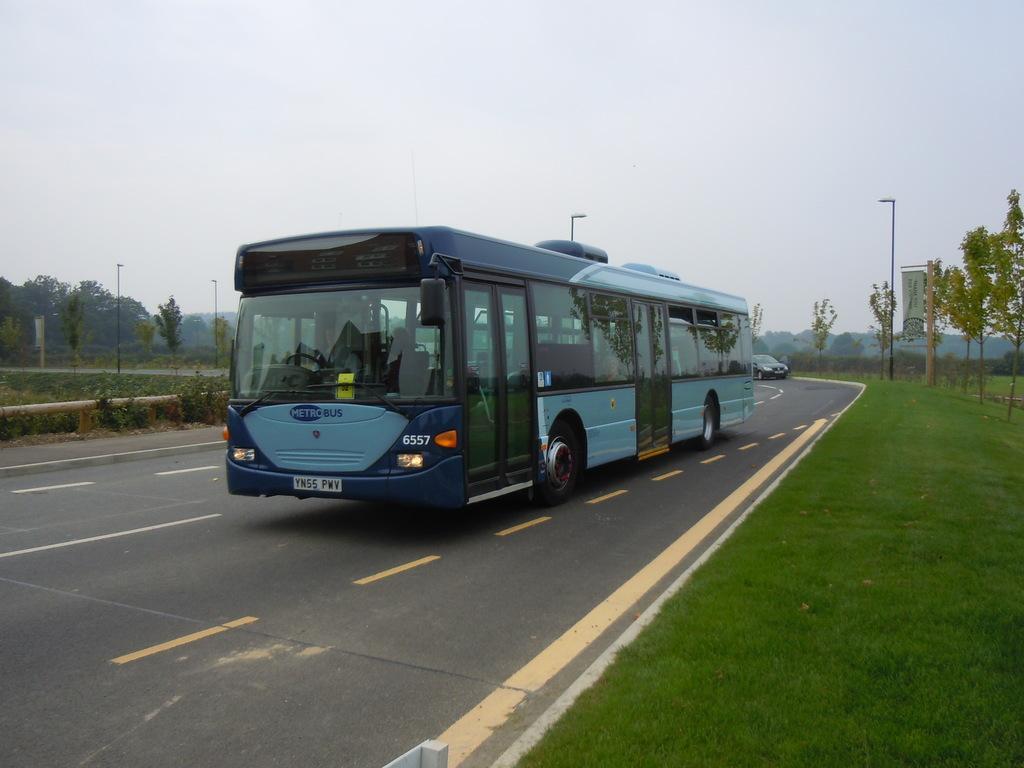Could you give a brief overview of what you see in this image? In this picture we can see a bus and a car on the road, and few people are seated in the bus, in the background we can see grass, poles, trees and hoardings. 